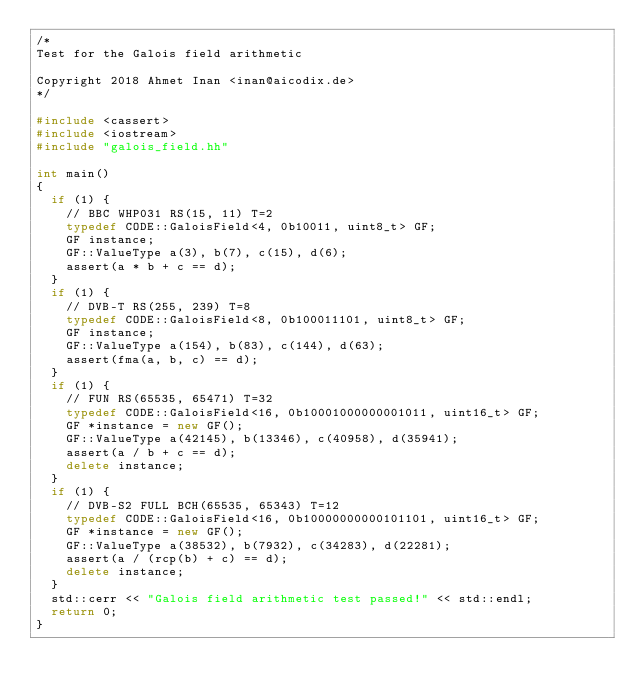<code> <loc_0><loc_0><loc_500><loc_500><_C++_>/*
Test for the Galois field arithmetic

Copyright 2018 Ahmet Inan <inan@aicodix.de>
*/

#include <cassert>
#include <iostream>
#include "galois_field.hh"

int main()
{
	if (1) {
		// BBC WHP031 RS(15, 11) T=2
		typedef CODE::GaloisField<4, 0b10011, uint8_t> GF;
		GF instance;
		GF::ValueType a(3), b(7), c(15), d(6);
		assert(a * b + c == d);
	}
	if (1) {
		// DVB-T RS(255, 239) T=8
		typedef CODE::GaloisField<8, 0b100011101, uint8_t> GF;
		GF instance;
		GF::ValueType a(154), b(83), c(144), d(63);
		assert(fma(a, b, c) == d);
	}
	if (1) {
		// FUN RS(65535, 65471) T=32
		typedef CODE::GaloisField<16, 0b10001000000001011, uint16_t> GF;
		GF *instance = new GF();
		GF::ValueType a(42145), b(13346), c(40958), d(35941);
		assert(a / b + c == d);
		delete instance;
	}
	if (1) {
		// DVB-S2 FULL BCH(65535, 65343) T=12
		typedef CODE::GaloisField<16, 0b10000000000101101, uint16_t> GF;
		GF *instance = new GF();
		GF::ValueType a(38532), b(7932), c(34283), d(22281);
		assert(a / (rcp(b) + c) == d);
		delete instance;
	}
	std::cerr << "Galois field arithmetic test passed!" << std::endl;
	return 0;
}

</code> 